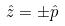Convert formula to latex. <formula><loc_0><loc_0><loc_500><loc_500>\hat { z } = \pm \hat { p }</formula> 